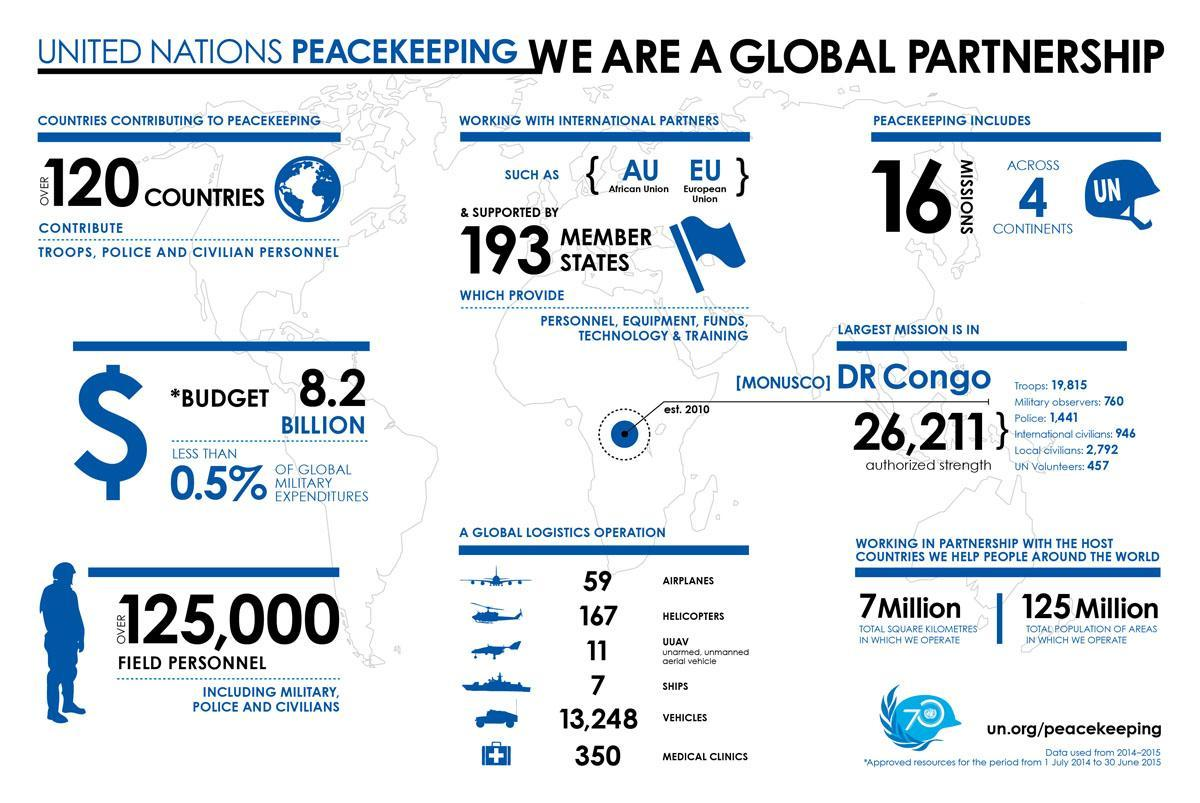How many military observers were deployed for the UN mission in Monusco?
Answer the question with a short phrase. 760 What is the total budget for the UN peace keeping missions in dollars? 8.2 BILLION How many countries contribute to the UN peace keeping missions? OVER 120 COUNTRIES How many troops were deployed for the UN mission in Monusco? 19,815 What is the total population of areas in which the UN peace keepers operate? 125 Million What is the total number of forces deployed for the UN mission in Monusco? 26,211 How many local civilians were deployed for the UN mission in Monusco? 2,792 How many UN peace keeping missions were deployed across different continents? 16 MISSIONS 